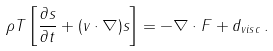<formula> <loc_0><loc_0><loc_500><loc_500>\rho T \left [ \frac { \partial s } { \partial t } + ( v \cdot \nabla ) s \right ] = - \nabla \cdot F + d _ { v i s c } \, .</formula> 